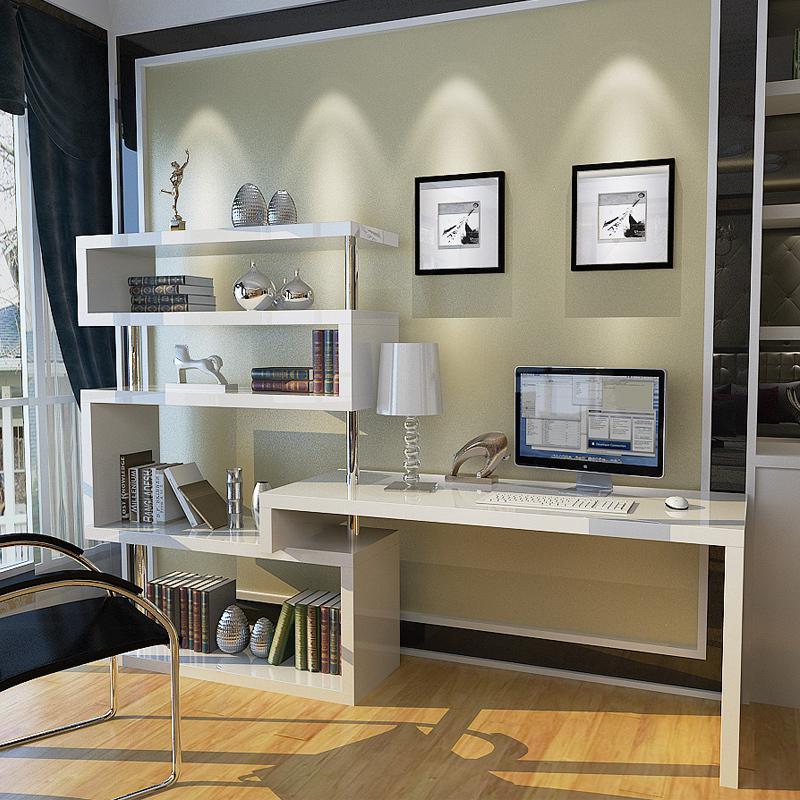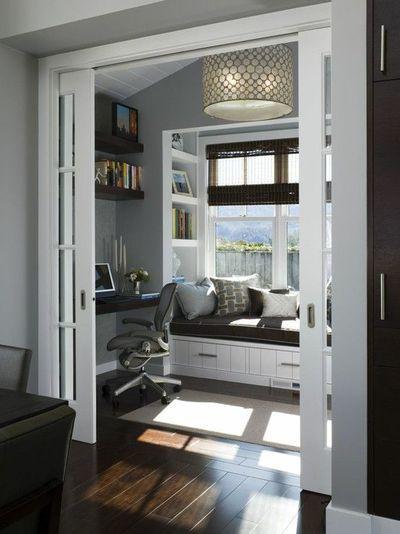The first image is the image on the left, the second image is the image on the right. Given the left and right images, does the statement "In one of the images, the desk chair is white." hold true? Answer yes or no. No. The first image is the image on the left, the second image is the image on the right. Evaluate the accuracy of this statement regarding the images: "Both desks have a computer or monitor visible.". Is it true? Answer yes or no. Yes. 